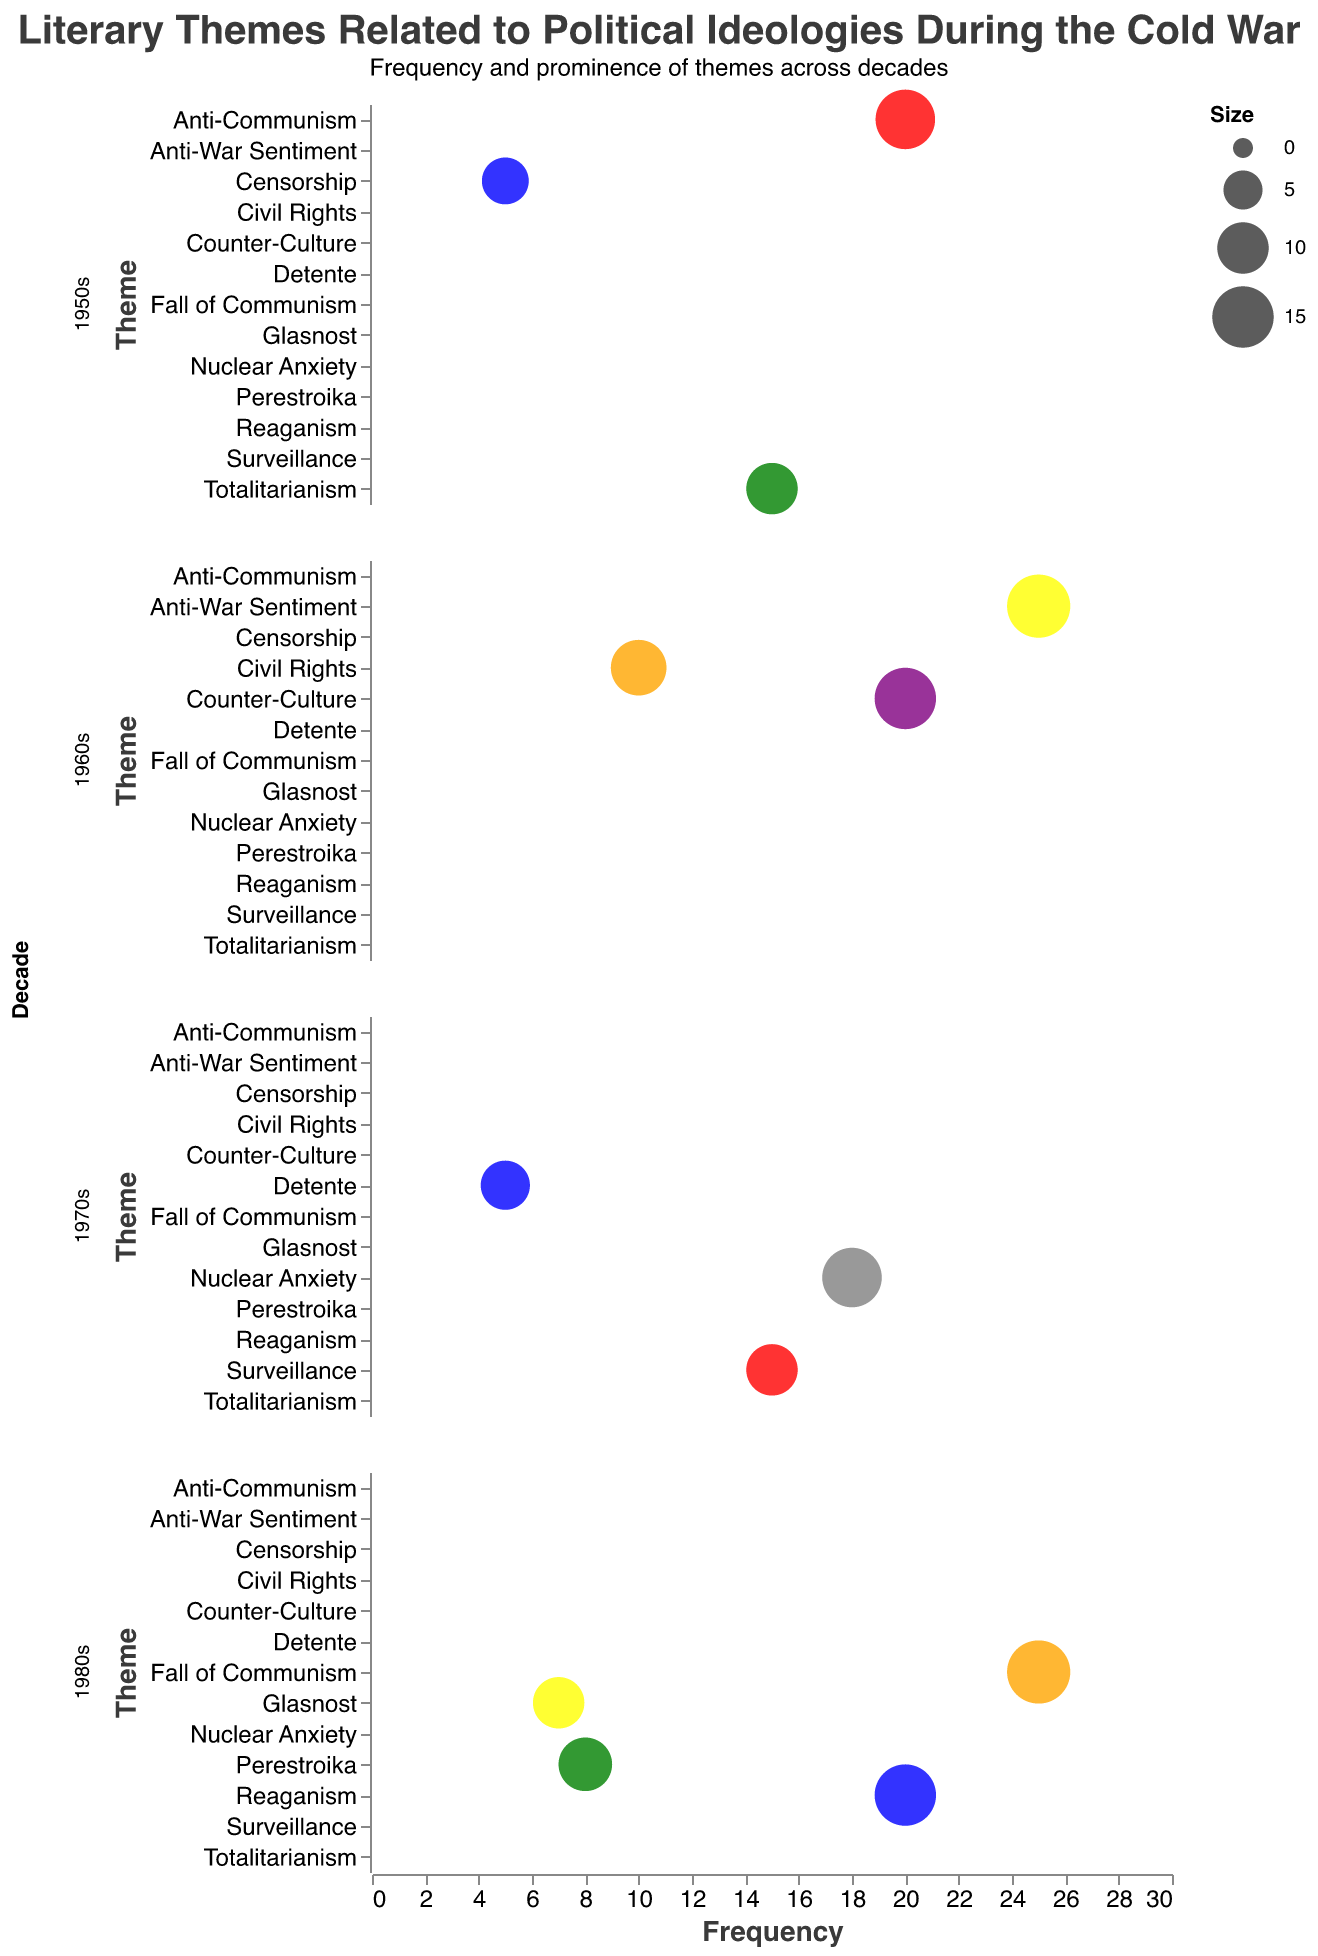Which theme in the 1950s has the highest frequency? First, identify the themes in the 1950s. Then, compare their frequencies. "Anti-Communism" has the highest frequency at 20.
Answer: Anti-Communism How many themes in the 1960s have a frequency higher than 15? Identify the themes in the 1960s and compare their frequencies to 15. "Anti-War Sentiment" and "Counter-Culture" both have frequencies higher than 15. Thus, there are 2 themes.
Answer: 2 Which decade has the theme with the highest frequency across the whole dataset? Compare the highest frequency of themes in each decade. "Anti-War Sentiment" and "Fall of Communism" both in the 1960s and 1980s respectively, each have the highest frequency of 25.
Answer: 1960s and 1980s What's the average frequency of themes in the 1970s? Sum the frequencies of themes in the 1970s (5 + 15 + 18 = 38) and divide by the number of themes (3). So, the average frequency is 38/3 ≈ 12.67.
Answer: 12.67 Which theme appears with the smallest bubble size, and in which decade? Identify the theme with the smallest "Size" value. The smallest bubble size of 8 is associated with "Censorship" in the 1950s.
Answer: Censorship, 1950s 